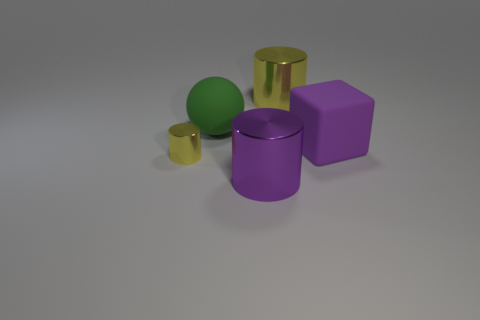Subtract all brown cubes. How many yellow cylinders are left? 2 Subtract all big cylinders. How many cylinders are left? 1 Add 2 big purple metal things. How many objects exist? 7 Subtract all blocks. How many objects are left? 4 Subtract all blue cylinders. Subtract all gray cubes. How many cylinders are left? 3 Subtract 1 green balls. How many objects are left? 4 Subtract all tiny yellow cylinders. Subtract all spheres. How many objects are left? 3 Add 2 metal cylinders. How many metal cylinders are left? 5 Add 5 big metallic objects. How many big metallic objects exist? 7 